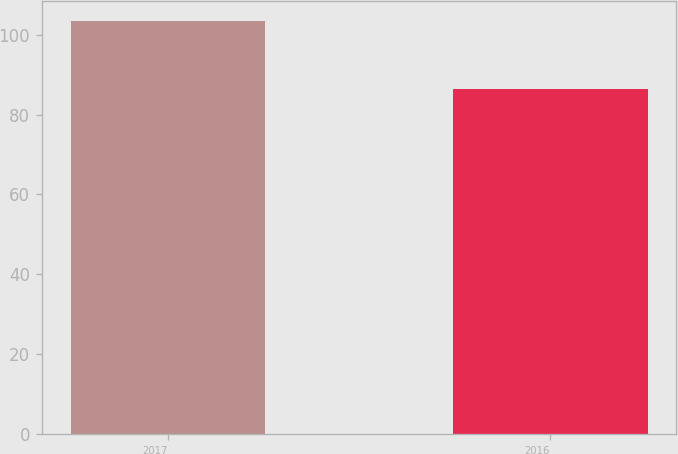Convert chart to OTSL. <chart><loc_0><loc_0><loc_500><loc_500><bar_chart><fcel>2017<fcel>2016<nl><fcel>103.36<fcel>86.5<nl></chart> 